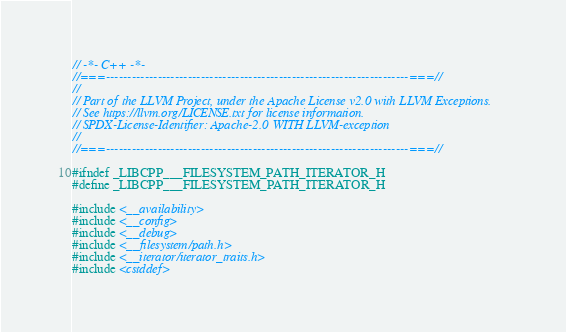Convert code to text. <code><loc_0><loc_0><loc_500><loc_500><_C_>// -*- C++ -*-
//===----------------------------------------------------------------------===//
//
// Part of the LLVM Project, under the Apache License v2.0 with LLVM Exceptions.
// See https://llvm.org/LICENSE.txt for license information.
// SPDX-License-Identifier: Apache-2.0 WITH LLVM-exception
//
//===----------------------------------------------------------------------===//

#ifndef _LIBCPP___FILESYSTEM_PATH_ITERATOR_H
#define _LIBCPP___FILESYSTEM_PATH_ITERATOR_H

#include <__availability>
#include <__config>
#include <__debug>
#include <__filesystem/path.h>
#include <__iterator/iterator_traits.h>
#include <cstddef></code> 